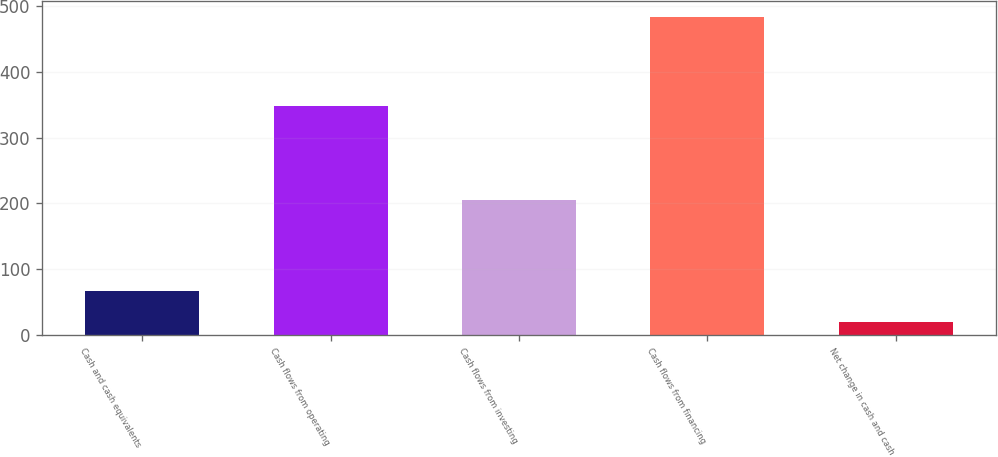Convert chart to OTSL. <chart><loc_0><loc_0><loc_500><loc_500><bar_chart><fcel>Cash and cash equivalents<fcel>Cash flows from operating<fcel>Cash flows from investing<fcel>Cash flows from financing<fcel>Net change in cash and cash<nl><fcel>66.4<fcel>348<fcel>205.6<fcel>484<fcel>20<nl></chart> 